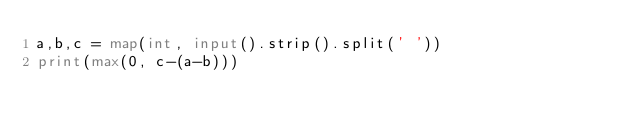Convert code to text. <code><loc_0><loc_0><loc_500><loc_500><_Python_>a,b,c = map(int, input().strip().split(' '))
print(max(0, c-(a-b)))</code> 